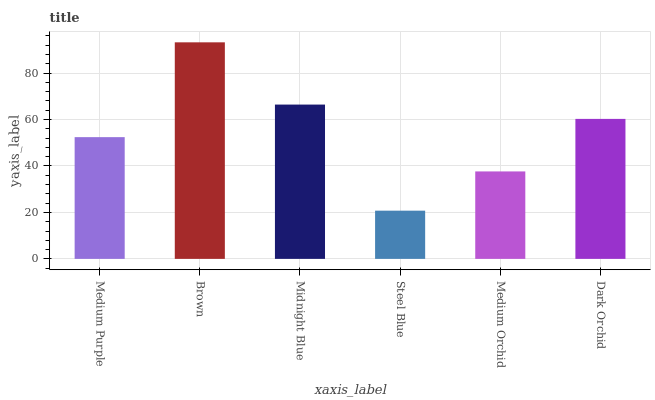Is Steel Blue the minimum?
Answer yes or no. Yes. Is Brown the maximum?
Answer yes or no. Yes. Is Midnight Blue the minimum?
Answer yes or no. No. Is Midnight Blue the maximum?
Answer yes or no. No. Is Brown greater than Midnight Blue?
Answer yes or no. Yes. Is Midnight Blue less than Brown?
Answer yes or no. Yes. Is Midnight Blue greater than Brown?
Answer yes or no. No. Is Brown less than Midnight Blue?
Answer yes or no. No. Is Dark Orchid the high median?
Answer yes or no. Yes. Is Medium Purple the low median?
Answer yes or no. Yes. Is Medium Purple the high median?
Answer yes or no. No. Is Midnight Blue the low median?
Answer yes or no. No. 